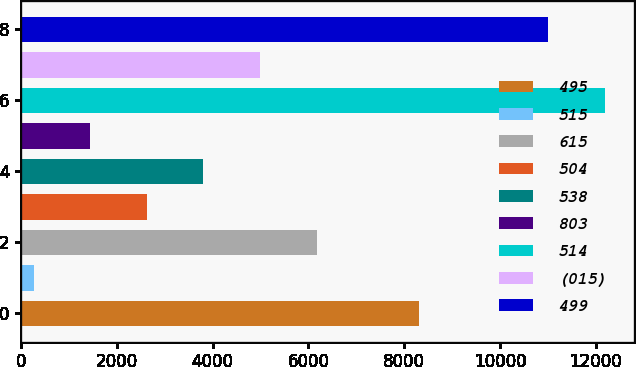<chart> <loc_0><loc_0><loc_500><loc_500><bar_chart><fcel>495<fcel>515<fcel>615<fcel>504<fcel>538<fcel>803<fcel>514<fcel>(015)<fcel>499<nl><fcel>8316<fcel>263<fcel>6170<fcel>2625.8<fcel>3807.2<fcel>1444.4<fcel>12194.4<fcel>4988.6<fcel>11013<nl></chart> 